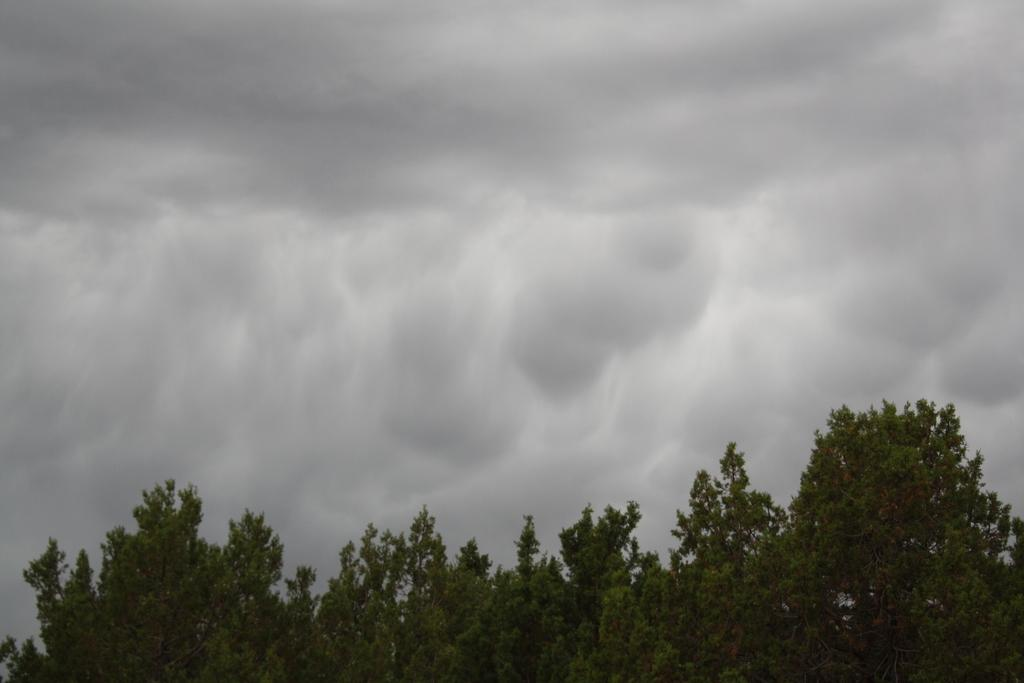What type of vegetation is present at the bottom of the picture? There are trees at the bottom of the picture. What part of the natural environment is visible at the top of the picture? The sky is visible at the top of the picture. What trick does the writer use to make the trees grow in the image? There is no writer present in the image, and the trees are not growing due to any tricks. 